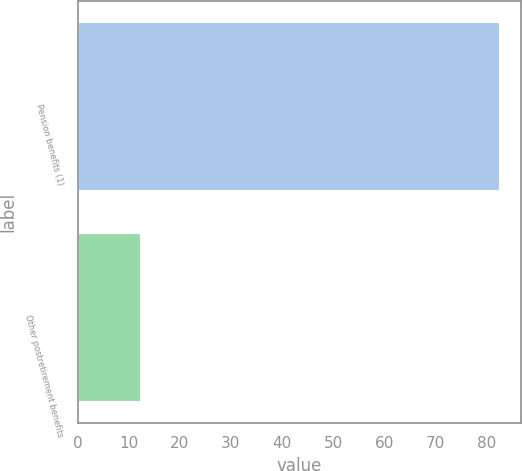Convert chart to OTSL. <chart><loc_0><loc_0><loc_500><loc_500><bar_chart><fcel>Pension benefits (1)<fcel>Other postretirement benefits<nl><fcel>82.6<fcel>12.4<nl></chart> 